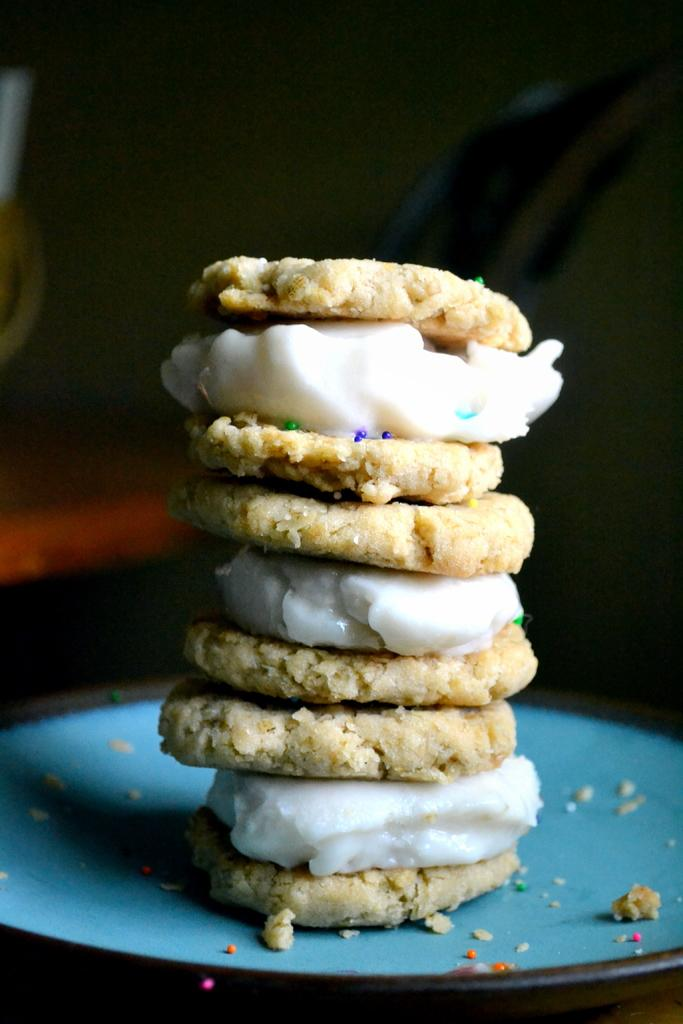What is present in the image related to food? There is food in the image. What is used to serve the food in the image? There is a plate in the image. Can you describe the background of the image? The background of the image is dark. How many donkeys can be seen grazing in the background of the image? There are no donkeys present in the image; the background is dark. What type of sound do the bells make in the image? There are no bells present in the image. 